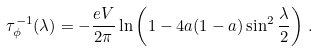<formula> <loc_0><loc_0><loc_500><loc_500>\tau ^ { - 1 } _ { \phi } ( \lambda ) = - \frac { e V } { 2 \pi } \ln \left ( 1 - 4 a ( 1 - a ) \sin ^ { 2 } \frac { \lambda } { 2 } \right ) \, .</formula> 